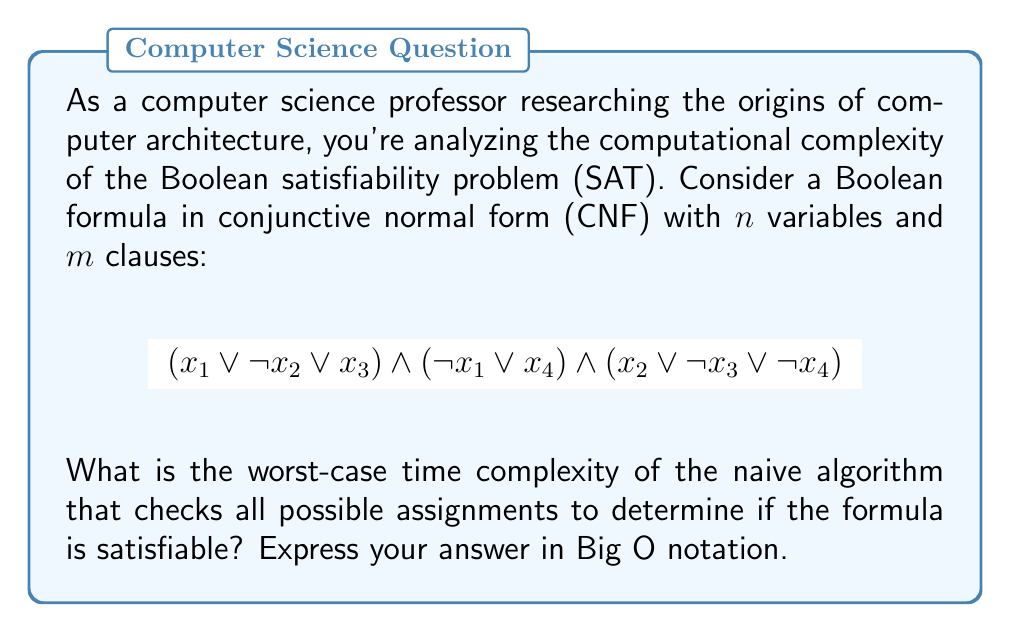Give your solution to this math problem. To analyze the worst-case time complexity of the naive algorithm for the Boolean satisfiability problem (SAT), we need to consider the following steps:

1. The number of variables in the given formula is $n = 4$.

2. In general, for a Boolean formula with $n$ variables, there are $2^n$ possible truth assignments. This is because each variable can be either true or false, resulting in $2$ choices for each of the $n$ variables.

3. The naive algorithm checks all possible assignments to determine if the formula is satisfiable. This means it will iterate through all $2^n$ combinations.

4. For each assignment, the algorithm needs to evaluate the entire formula. In the worst case, this evaluation takes time proportional to the size of the formula, which is $O(m)$, where $m$ is the number of clauses.

5. Therefore, the total time complexity is the product of the number of assignments and the time to evaluate each assignment:

   $$O(2^n \cdot m)$$

6. In Big O notation, we typically express the complexity in terms of the input size. Since $m$ could potentially be exponential in $n$ (in the worst case), we usually consider $n$ as the primary input size for SAT problems.

7. Thus, we can simplify the expression to:

   $$O(2^n)$$

This exponential time complexity demonstrates why SAT is considered an NP-complete problem, and why more sophisticated algorithms and heuristics are necessary for solving SAT instances in practice.
Answer: $O(2^n)$ 